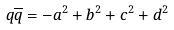Convert formula to latex. <formula><loc_0><loc_0><loc_500><loc_500>q \overline { q } = - a ^ { 2 } + b ^ { 2 } + c ^ { 2 } + d ^ { 2 }</formula> 